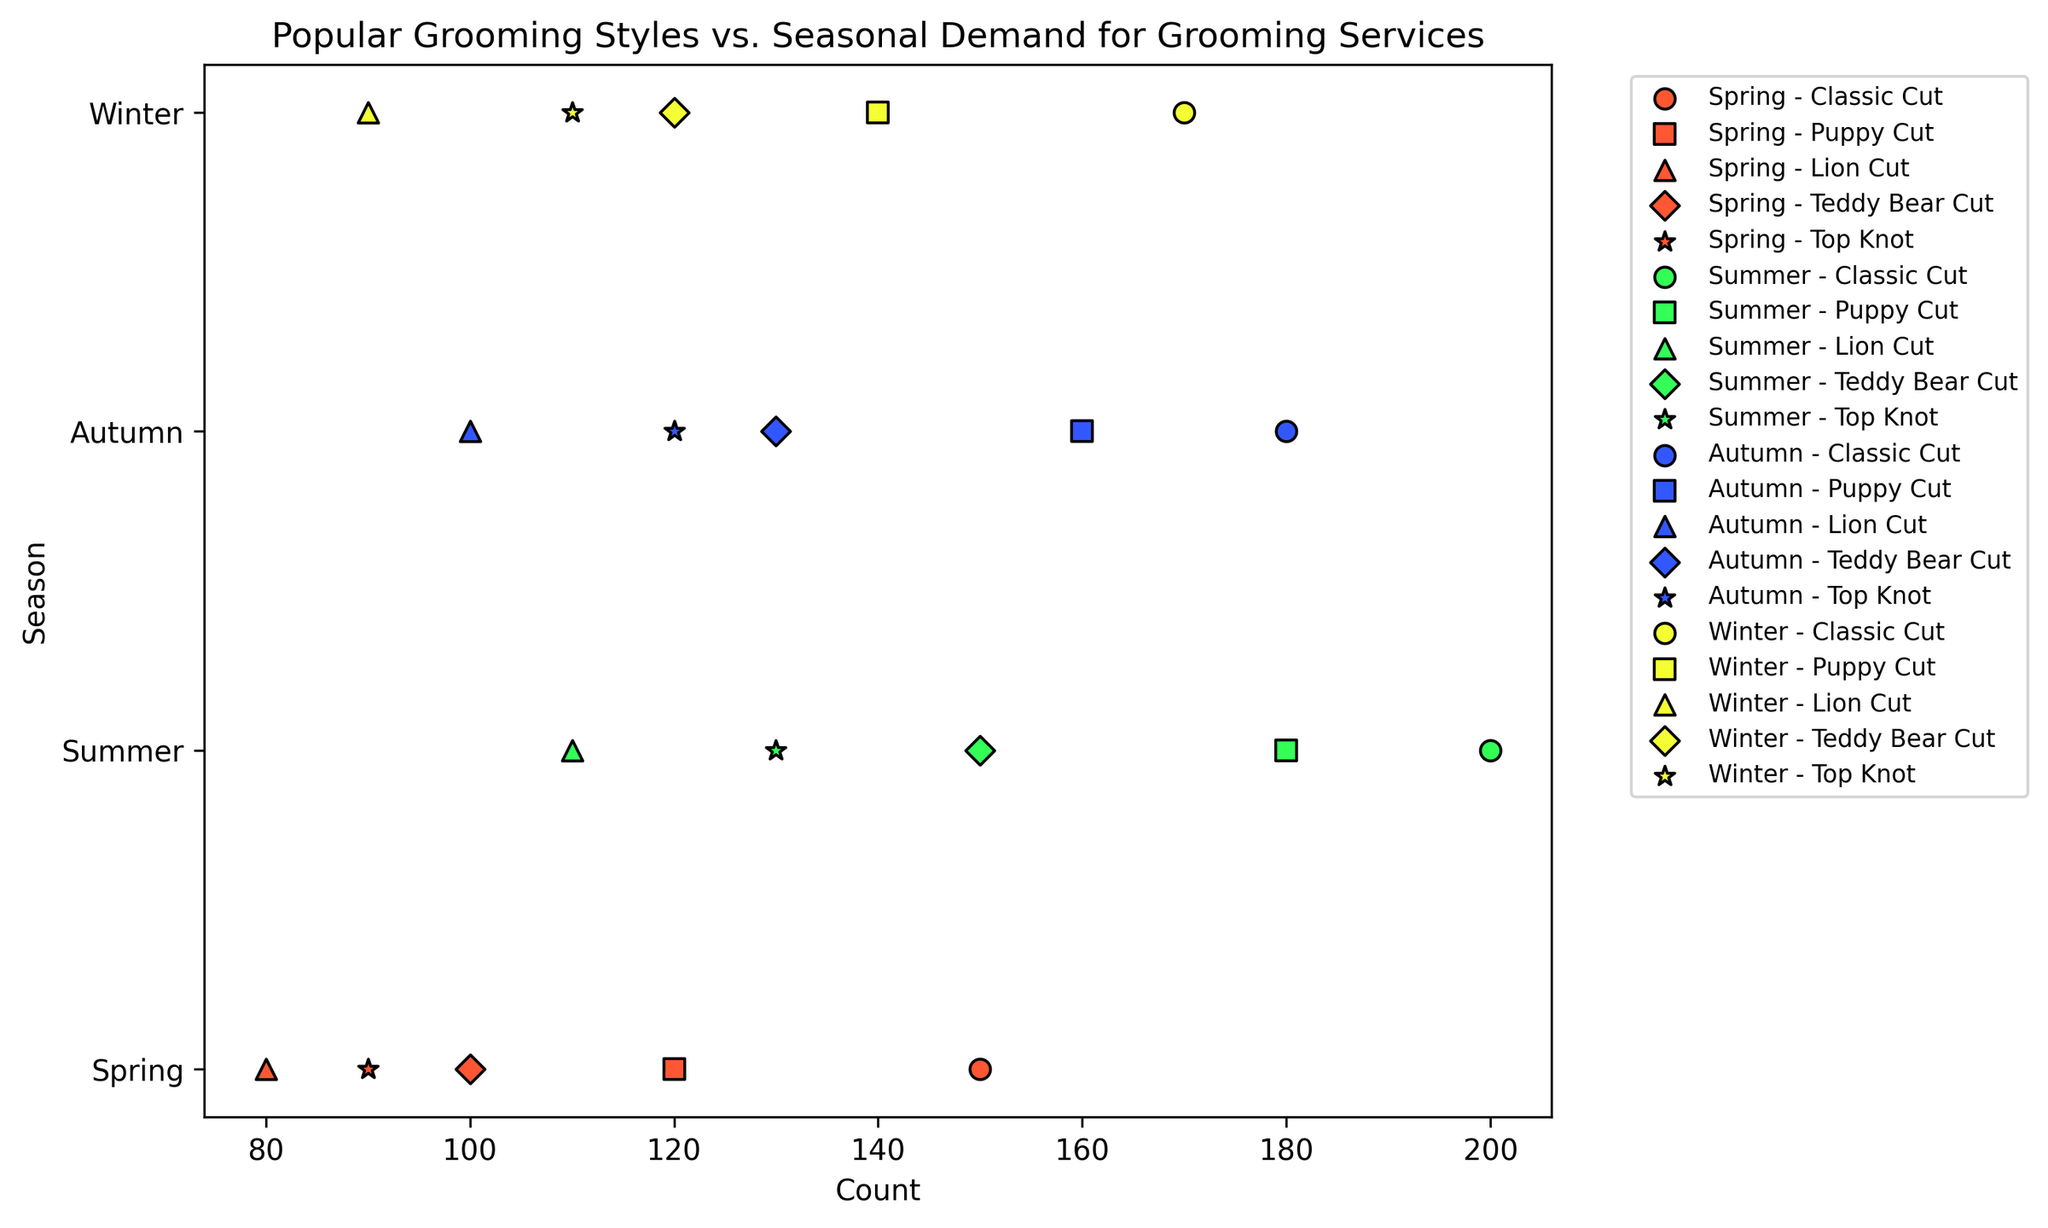Which grooming style is most popular in Summer? By examining the scatter plot, look for the style with the highest count value in Summer. It appears to be the Classic Cut with 200 counts.
Answer: Classic Cut Which season has the lowest demand for the Lion Cut style? Locate points corresponding to the Lion Cut style across all seasons and compare their values. The Spring season has the Lion Cut with the lowest count of 80.
Answer: Spring Compare the demand for the Teddy Bear Cut in Autumn and Summer. Which one is higher, and by how much? Find the points representing the Teddy Bear Cut in both Autumn and Summer. The count for the Teddy Bear Cut is 130 in Autumn and 150 in Summer. Subtract the Autumn count from the Summer count: 150 - 130 = 20.
Answer: Summer is higher by 20 What is the total demand for the Classic Cut across all seasons? Add up the counts of the Classic Cut for all seasons: 150 (Spring) + 200 (Summer) + 180 (Autumn) + 170 (Winter) = 700.
Answer: 700 What is the average demand for the Top Knot style in all seasons? Sum the counts of the Top Knot style across all seasons and divide by the number of seasons: (90 + 130 + 120 + 110) / 4 = 450 / 4 = 112.5.
Answer: 112.5 Which grooming style has the highest demand in Autumn? Find the highest-count point in Autumn. The Classic Cut has the highest count in Autumn with 180.
Answer: Classic Cut Is the demand for the Puppy Cut in Winter greater than in Spring? Compare the counts of the Puppy Cut in Winter and Spring. The count in Winter is 140, and in Spring, it is 120. Yes, the demand in Winter is greater.
Answer: Yes By how much does the demand for the Lion Cut increase from Spring to Summer? Subtract the Spring Lion Cut count from the Summer Lion Cut count: 110 (Summer) - 80 (Spring) = 30.
Answer: Increases by 30 Which style experiences the least fluctuation in demand across the seasons? Examine the range (difference between the highest and lowest counts) for each style across all seasons. The Classic Cut has a range (200 - 150) = 50, the Puppy Cut has a range (180 - 120) = 60, the Lion Cut has a range (110 - 80) = 30, the Teddy Bear Cut has a range (150 - 100) = 50, and the Top Knot has a range (130 - 90) = 40. The Lion Cut has the smallest range.
Answer: Lion Cut 